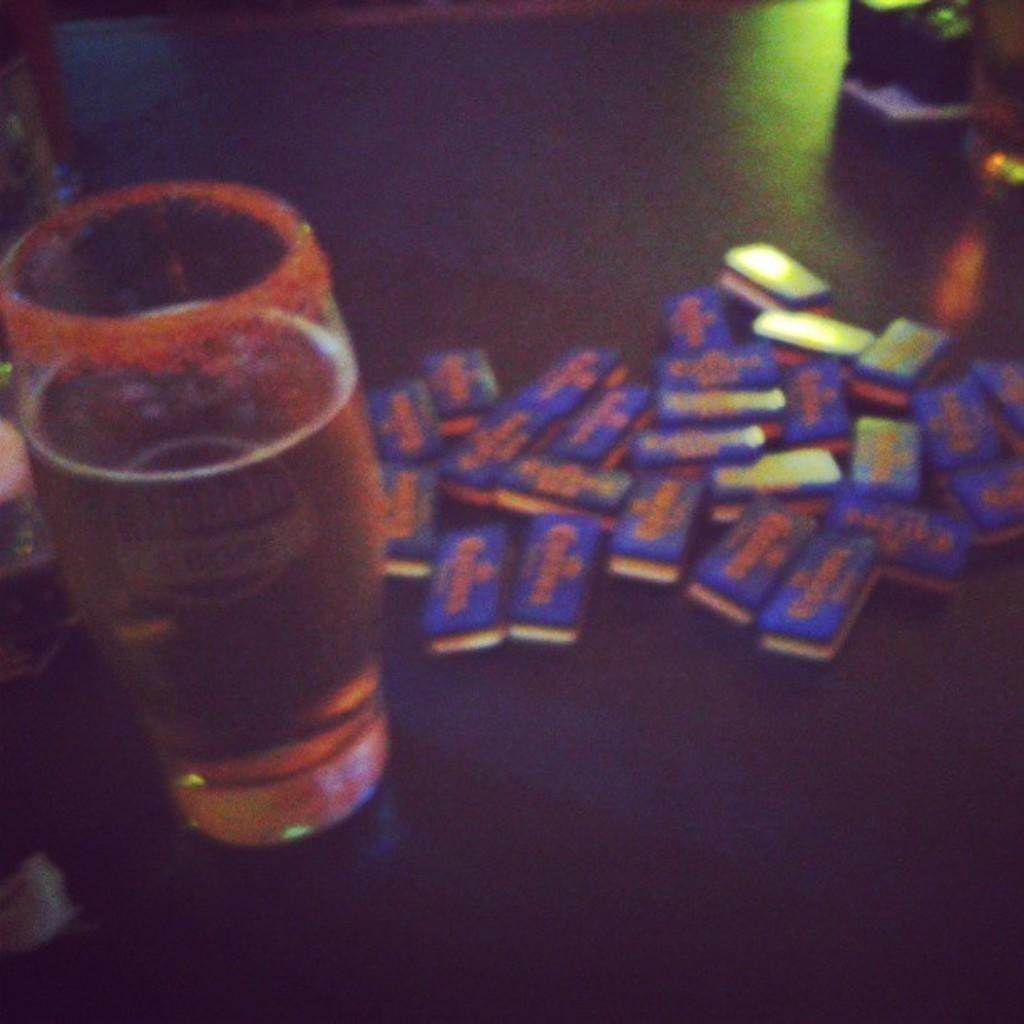Please provide a concise description of this image. In this image I can see on the left side there is a beer glass. On the right side it looks like there are chocolates. 